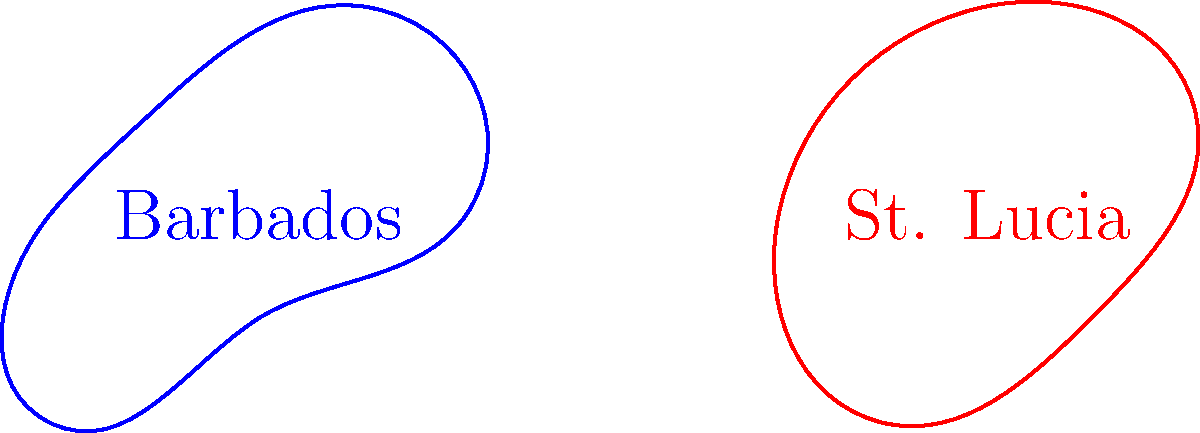The simplified coastlines of Barbados and St. Lucia are shown above. Considering the genus of these surfaces, which statement is true? To determine the genus of these surfaces, we need to follow these steps:

1. Understand the concept of genus:
   - The genus of a surface is the maximum number of simple closed curves that can be drawn on the surface without separating it into distinct regions.
   - For a closed surface, it's equivalent to the number of "handles" or "holes" in the surface.

2. Analyze Barbados:
   - The coastline of Barbados forms a simple closed curve without any holes.
   - This is topologically equivalent to a disk or a sphere.
   - The genus of a sphere is 0.

3. Analyze St. Lucia:
   - The coastline of St. Lucia also forms a simple closed curve without any holes.
   - This is also topologically equivalent to a disk or a sphere.
   - The genus of St. Lucia's surface is also 0.

4. Compare the two islands:
   - Both Barbados and St. Lucia have a genus of 0.
   - Topologically, they are equivalent to each other and to a sphere.

5. Consider the implications:
   - The genus doesn't capture the detailed shape of the coastline, only its overall topology.
   - Despite their different shapes, both islands are topologically simple and have no "handles" or "holes".

Therefore, the true statement is that both Barbados and St. Lucia have the same genus, which is 0.
Answer: Both islands have genus 0. 